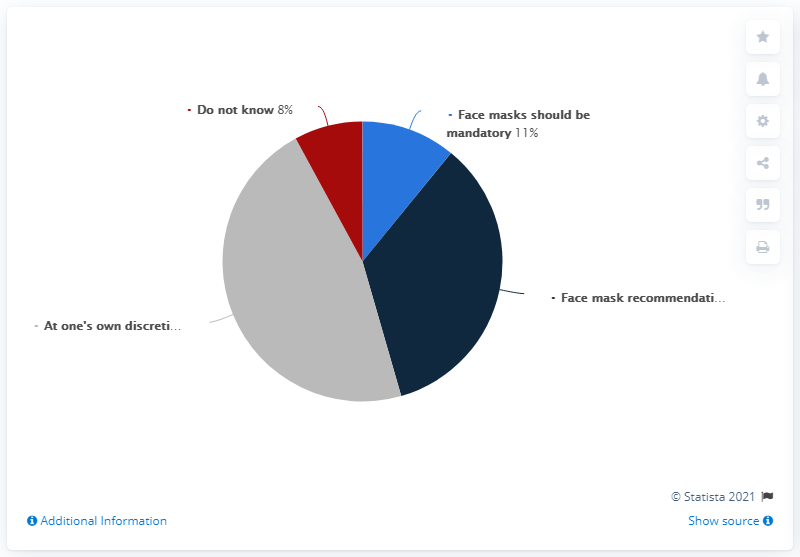Give some essential details in this illustration. According to a recent survey, 11% of Finnish people believe that face masks should be mandatory in all public spaces. It is indicated that face masks should be mandatory due to the light blue color that is present. The use of face masks should be mandatory in order to maintain public health and prevent the spread of COVID-19. It is recommended that face masks be worn in public places, especially during outbreaks of the disease. 